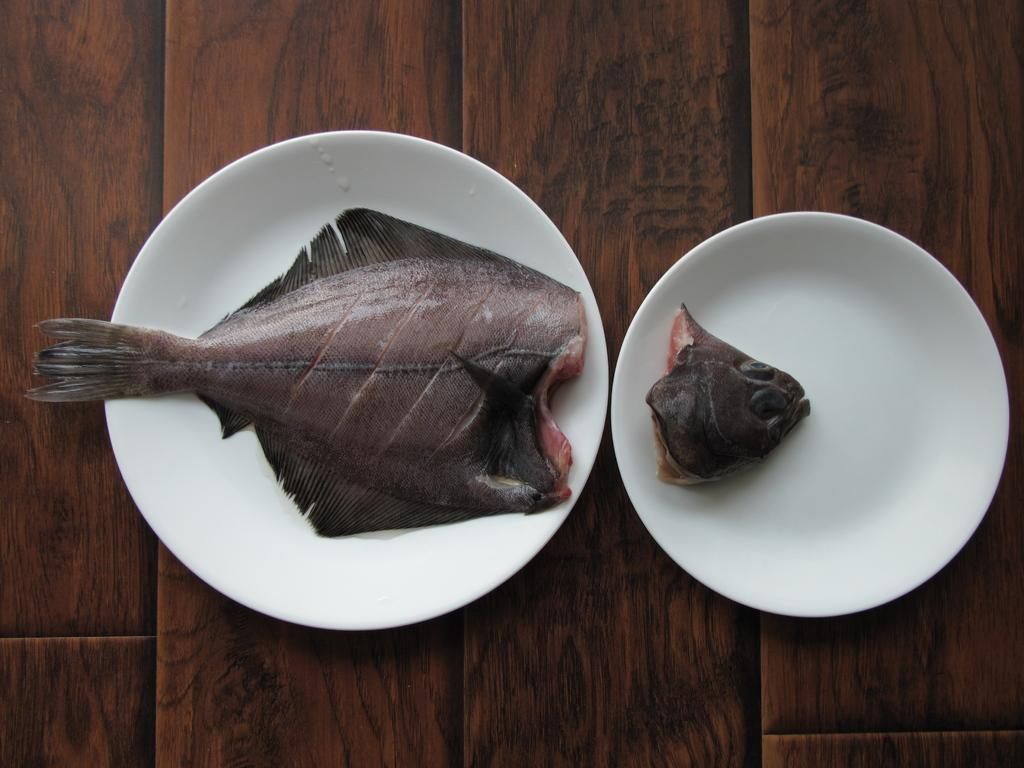What type of food is depicted in the image? The image contains fish bodies and fish heads. How are the fish bodies and fish heads arranged in the image? The fish bodies and fish heads are on plates. What is the surface on which the plates are placed? The plates are on a wooden platform. What activity is the fish participating in the image? There are no fish participating in any activity in the image, as the fish bodies and fish heads are presented as food on plates. 